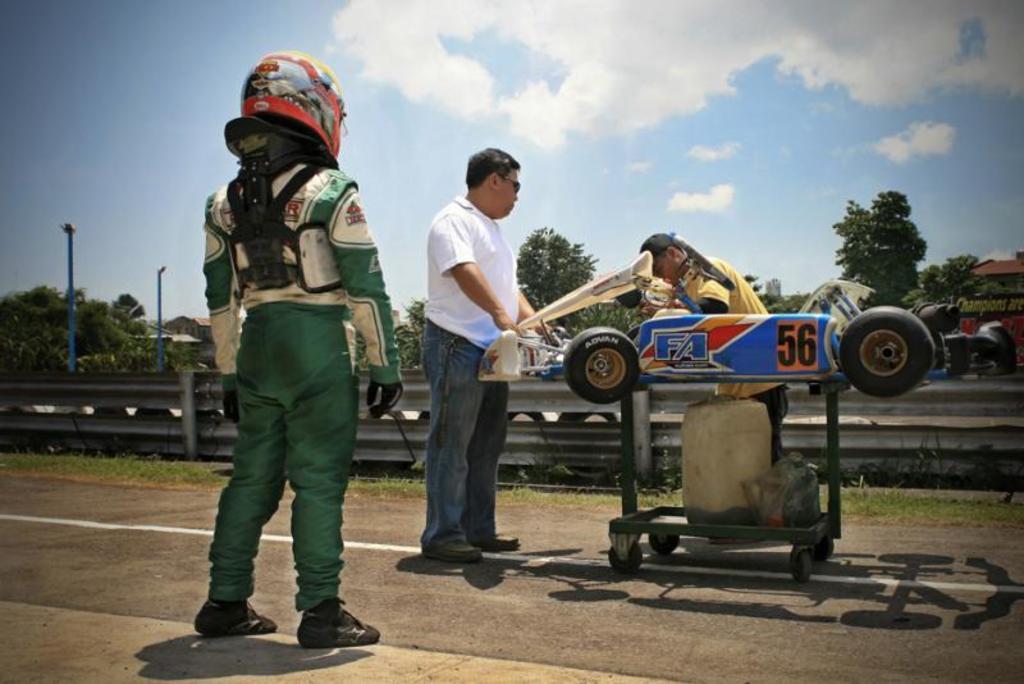Can you describe this image briefly? In the center of the image two mans are standing and holding a vehicle present on a trolley. We can see container, wheels and some objects are present. On the left side of the image a person is standing and wearing helmet. In the background of the image we can see trees, electric light pole, buildings are present. At the bottom of the image road is there. At the top of the image clouds are present in the sky. 